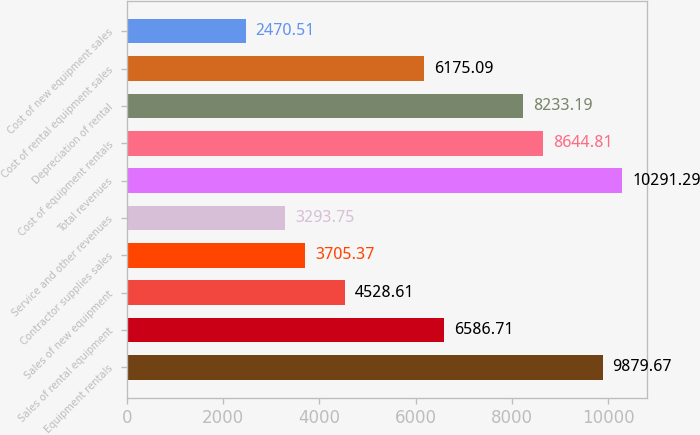Convert chart to OTSL. <chart><loc_0><loc_0><loc_500><loc_500><bar_chart><fcel>Equipment rentals<fcel>Sales of rental equipment<fcel>Sales of new equipment<fcel>Contractor supplies sales<fcel>Service and other revenues<fcel>Total revenues<fcel>Cost of equipment rentals<fcel>Depreciation of rental<fcel>Cost of rental equipment sales<fcel>Cost of new equipment sales<nl><fcel>9879.67<fcel>6586.71<fcel>4528.61<fcel>3705.37<fcel>3293.75<fcel>10291.3<fcel>8644.81<fcel>8233.19<fcel>6175.09<fcel>2470.51<nl></chart> 